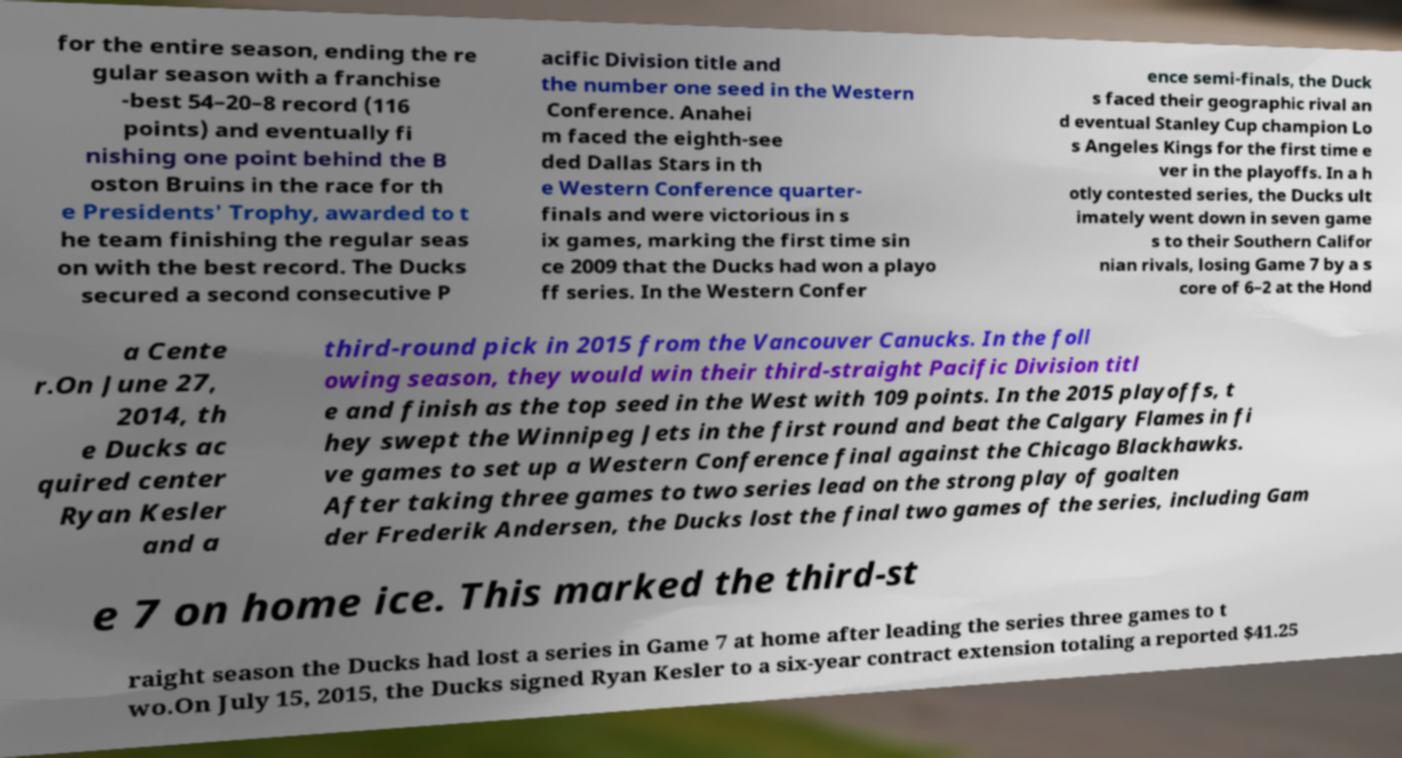Can you accurately transcribe the text from the provided image for me? for the entire season, ending the re gular season with a franchise -best 54–20–8 record (116 points) and eventually fi nishing one point behind the B oston Bruins in the race for th e Presidents' Trophy, awarded to t he team finishing the regular seas on with the best record. The Ducks secured a second consecutive P acific Division title and the number one seed in the Western Conference. Anahei m faced the eighth-see ded Dallas Stars in th e Western Conference quarter- finals and were victorious in s ix games, marking the first time sin ce 2009 that the Ducks had won a playo ff series. In the Western Confer ence semi-finals, the Duck s faced their geographic rival an d eventual Stanley Cup champion Lo s Angeles Kings for the first time e ver in the playoffs. In a h otly contested series, the Ducks ult imately went down in seven game s to their Southern Califor nian rivals, losing Game 7 by a s core of 6–2 at the Hond a Cente r.On June 27, 2014, th e Ducks ac quired center Ryan Kesler and a third-round pick in 2015 from the Vancouver Canucks. In the foll owing season, they would win their third-straight Pacific Division titl e and finish as the top seed in the West with 109 points. In the 2015 playoffs, t hey swept the Winnipeg Jets in the first round and beat the Calgary Flames in fi ve games to set up a Western Conference final against the Chicago Blackhawks. After taking three games to two series lead on the strong play of goalten der Frederik Andersen, the Ducks lost the final two games of the series, including Gam e 7 on home ice. This marked the third-st raight season the Ducks had lost a series in Game 7 at home after leading the series three games to t wo.On July 15, 2015, the Ducks signed Ryan Kesler to a six-year contract extension totaling a reported $41.25 